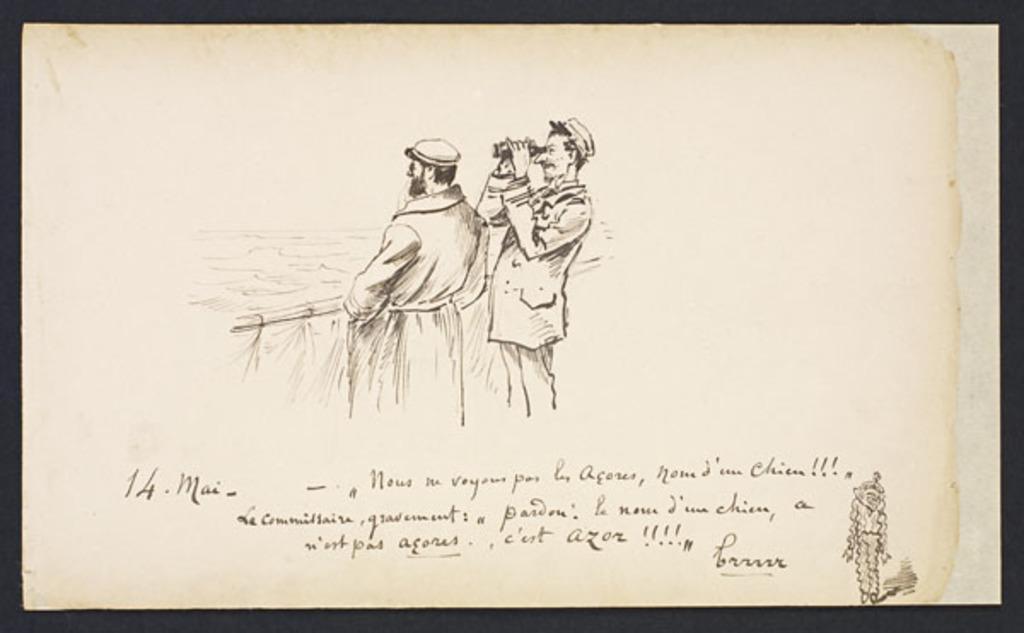Describe this image in one or two sentences. In the image we can see a paper, on the paper we can see drawing of two people, they are wearing clothes and a hat. There is a text and this is an object. 